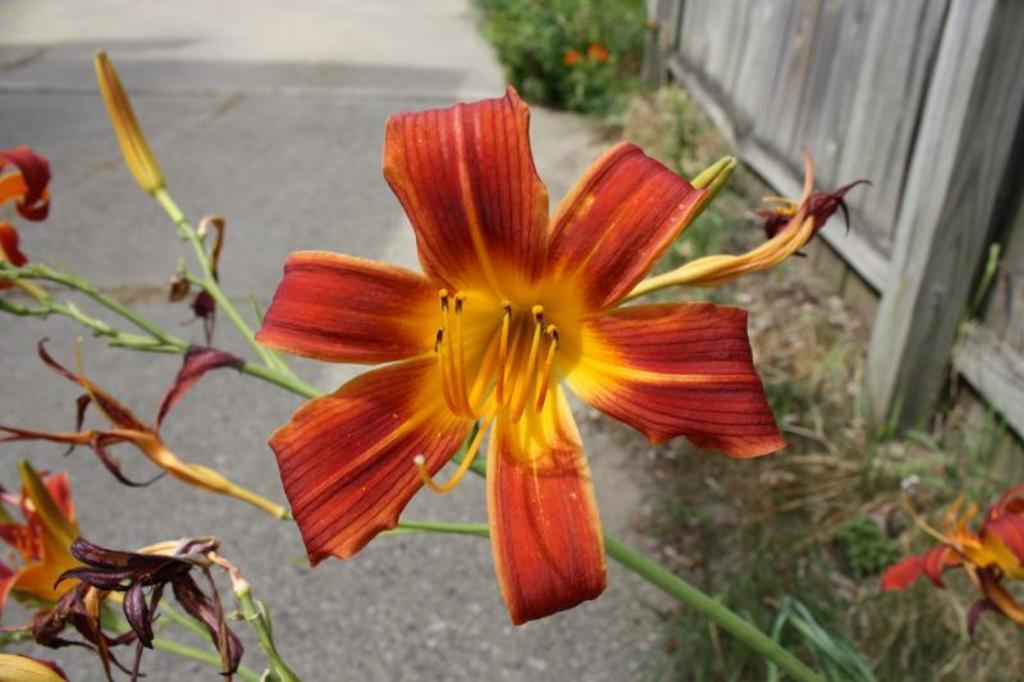How would you summarize this image in a sentence or two? In the image there is a flower plant in the front and behind its road with plants on the left side in front of the fence. 